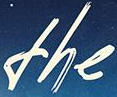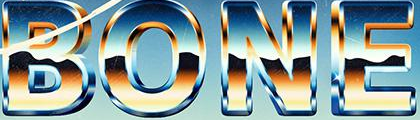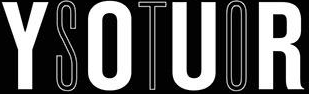What words can you see in these images in sequence, separated by a semicolon? the; BONE; YOUR 